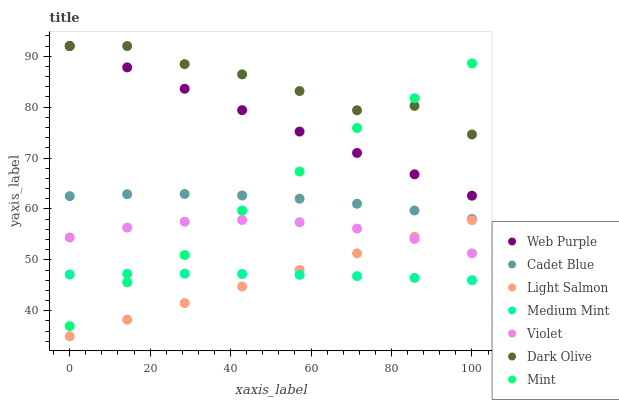Does Light Salmon have the minimum area under the curve?
Answer yes or no. Yes. Does Dark Olive have the maximum area under the curve?
Answer yes or no. Yes. Does Cadet Blue have the minimum area under the curve?
Answer yes or no. No. Does Cadet Blue have the maximum area under the curve?
Answer yes or no. No. Is Light Salmon the smoothest?
Answer yes or no. Yes. Is Dark Olive the roughest?
Answer yes or no. Yes. Is Cadet Blue the smoothest?
Answer yes or no. No. Is Cadet Blue the roughest?
Answer yes or no. No. Does Light Salmon have the lowest value?
Answer yes or no. Yes. Does Cadet Blue have the lowest value?
Answer yes or no. No. Does Web Purple have the highest value?
Answer yes or no. Yes. Does Light Salmon have the highest value?
Answer yes or no. No. Is Light Salmon less than Web Purple?
Answer yes or no. Yes. Is Web Purple greater than Light Salmon?
Answer yes or no. Yes. Does Mint intersect Dark Olive?
Answer yes or no. Yes. Is Mint less than Dark Olive?
Answer yes or no. No. Is Mint greater than Dark Olive?
Answer yes or no. No. Does Light Salmon intersect Web Purple?
Answer yes or no. No. 